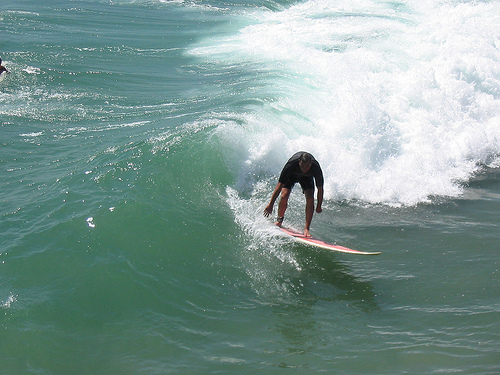Please provide a short description for this region: [0.53, 0.39, 0.68, 0.58]. This region depicts a surfer leaning forward on a surfboard, capturing an intense action moment on the wave. 